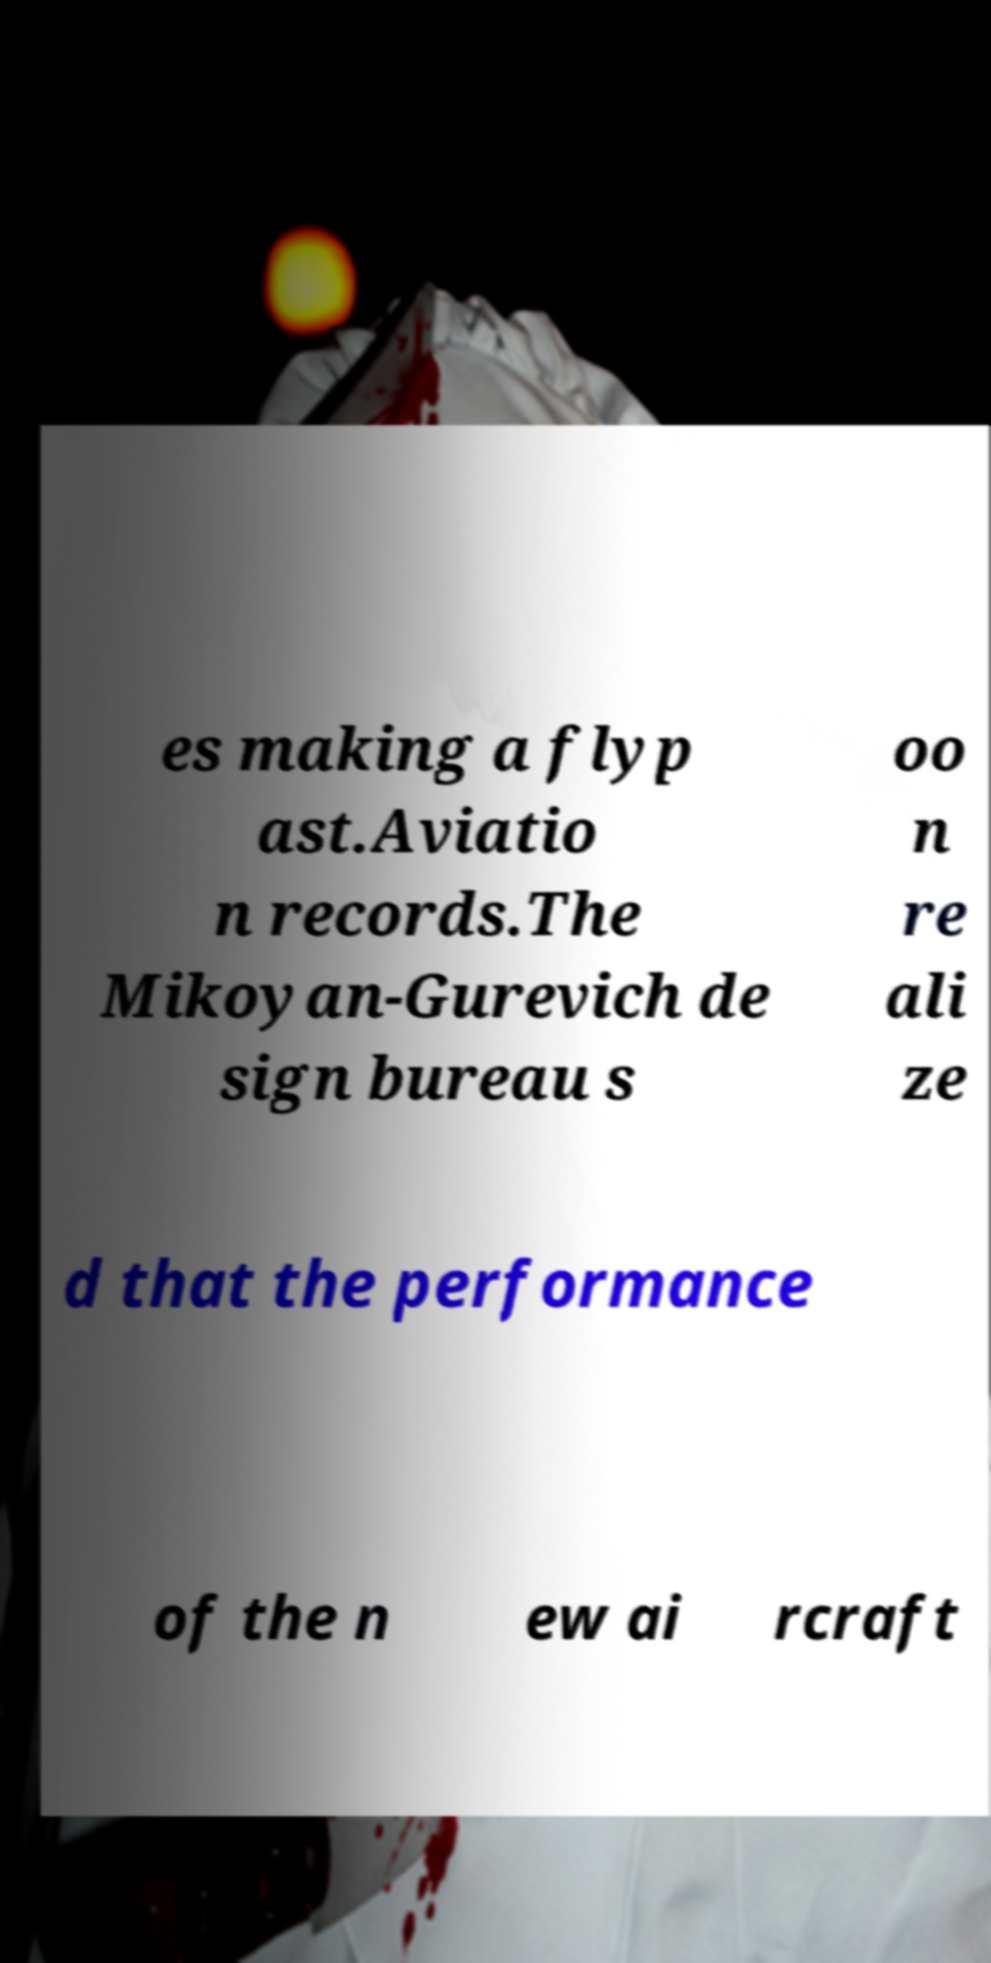Could you assist in decoding the text presented in this image and type it out clearly? es making a flyp ast.Aviatio n records.The Mikoyan-Gurevich de sign bureau s oo n re ali ze d that the performance of the n ew ai rcraft 